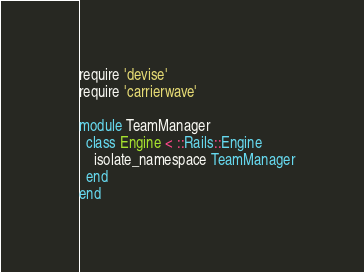Convert code to text. <code><loc_0><loc_0><loc_500><loc_500><_Ruby_>require 'devise'
require 'carrierwave'

module TeamManager
  class Engine < ::Rails::Engine
    isolate_namespace TeamManager
  end
end
</code> 